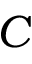Convert formula to latex. <formula><loc_0><loc_0><loc_500><loc_500>C</formula> 